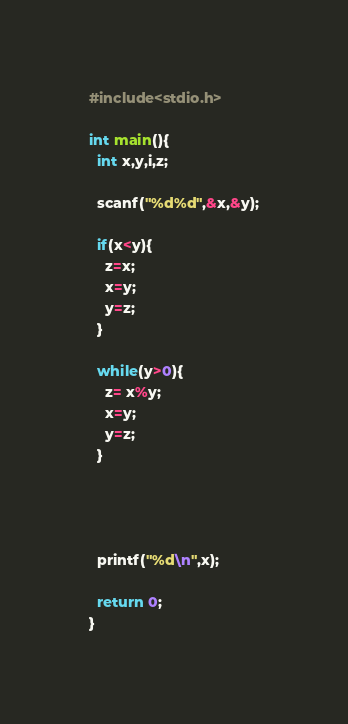<code> <loc_0><loc_0><loc_500><loc_500><_C_>#include<stdio.h>

int main(){
  int x,y,i,z;

  scanf("%d%d",&x,&y);

  if(x<y){
    z=x;
    x=y;
    y=z;
  }

  while(y>0){
    z= x%y;
    x=y;
    y=z;
  }
    
    


  printf("%d\n",x);
  
  return 0;
}


</code> 